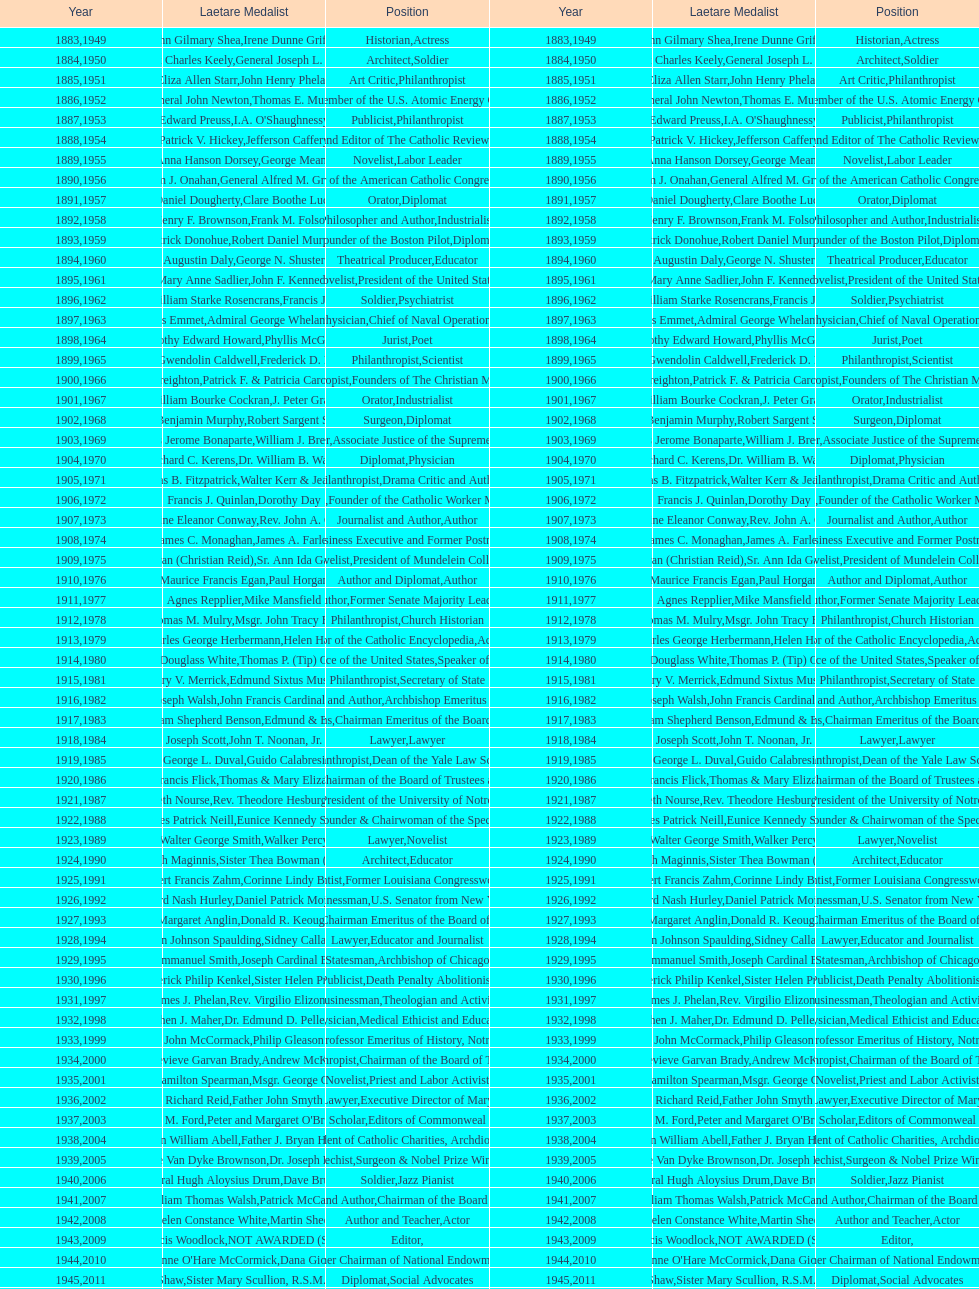How many attorneys have received the award between 1883 and 2014? 5. 